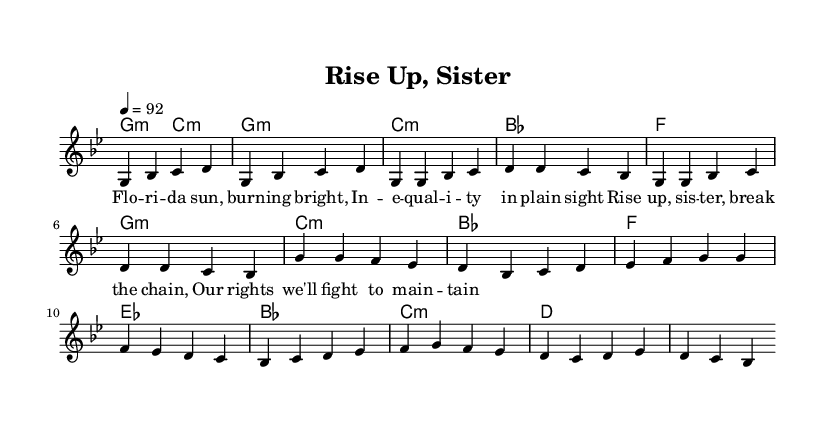What is the key signature of this music? The key signature is indicated in the global section and shows g minor, which has two flats (B flat and E flat).
Answer: g minor What is the time signature of this music? The time signature is displayed in the global section and is noted as 4/4 time, which means there are four beats in each measure.
Answer: 4/4 What is the tempo marking for this song? The tempo marking in the global section indicates the speed of the piece, which is marked as a quarter note equals 92 beats per minute.
Answer: 92 How many measures are in the verse? To find the number of measures in the verse, I count the measures specified under the melody and lyrics for the verse, which totals five measures.
Answer: 5 What is the primary theme reflected in the lyrics? By analyzing the lyrics, they emphasize empowerment and fighting against inequality, capturing a feminist perspective battling through struggles.
Answer: Empowerment Which chord is used in the chorus? The chords listed in the harmonies section show that the chorus primarily uses the chords G minor, C minor, and B flat in alternating measures.
Answer: G minor What musical style does this piece represent? The combination of rhythms, lyrical focus on gender equality, and the overall thematic content signifies that this piece is a feminist anthem in the style of rap.
Answer: Rap 